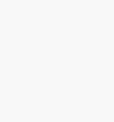<code> <loc_0><loc_0><loc_500><loc_500><_Scheme_>  </code> 